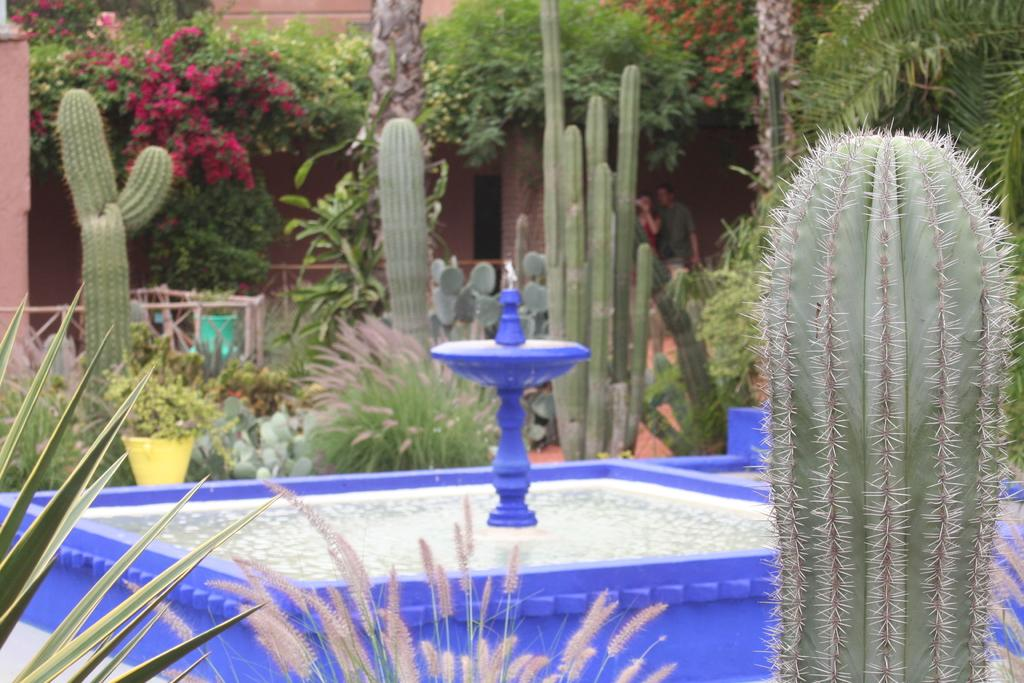What is the main feature in the image? There is a water fountain in the image. What type of plants can be seen in the image? There are cactus plants and green color plants in the image. Are there any flowers present in the image? Yes, there are flowers in the image. What type of pizzas are being served in the image? There are no pizzas present in the image; it features a water fountain, cactus plants, green color plants, and flowers. Can you provide a list of all the items in the image? The image contains a water fountain, cactus plants, green color plants, and flowers. 